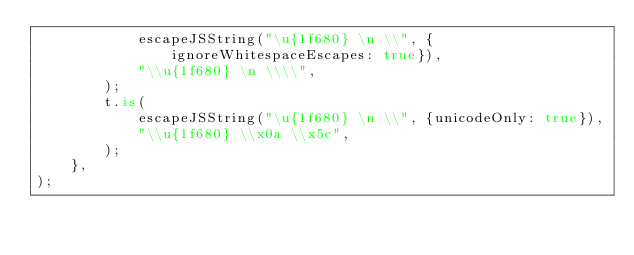<code> <loc_0><loc_0><loc_500><loc_500><_TypeScript_>			escapeJSString("\u{1f680} \n \\", {ignoreWhitespaceEscapes: true}),
			"\\u{1f680} \n \\\\",
		);
		t.is(
			escapeJSString("\u{1f680} \n \\", {unicodeOnly: true}),
			"\\u{1f680} \\x0a \\x5c",
		);
	},
);
</code> 